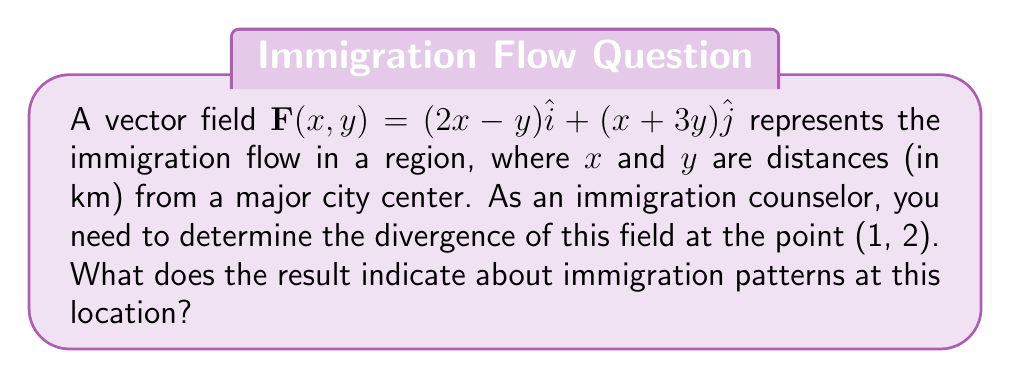Could you help me with this problem? To solve this problem, we need to follow these steps:

1) The divergence of a 2D vector field $\mathbf{F}(x,y) = P(x,y)\hat{i} + Q(x,y)\hat{j}$ is given by:

   $$\nabla \cdot \mathbf{F} = \frac{\partial P}{\partial x} + \frac{\partial Q}{\partial y}$$

2) In our case, $P(x,y) = 2x-y$ and $Q(x,y) = x+3y$

3) Calculate $\frac{\partial P}{\partial x}$:
   $$\frac{\partial P}{\partial x} = \frac{\partial}{\partial x}(2x-y) = 2$$

4) Calculate $\frac{\partial Q}{\partial y}$:
   $$\frac{\partial Q}{\partial y} = \frac{\partial}{\partial y}(x+3y) = 3$$

5) Sum these partial derivatives:
   $$\nabla \cdot \mathbf{F} = \frac{\partial P}{\partial x} + \frac{\partial Q}{\partial y} = 2 + 3 = 5$$

6) This result is constant for all points in the field, including (1, 2).

7) Interpretation: A positive divergence indicates that the point (1, 2) is a source in the immigration flow. This means that at this location, 1 km east and 2 km north of the city center, there is a net outflow of immigrants. The magnitude of 5 suggests a significant rate of outflow.
Answer: 5; indicates significant outflow of immigrants at (1, 2) 